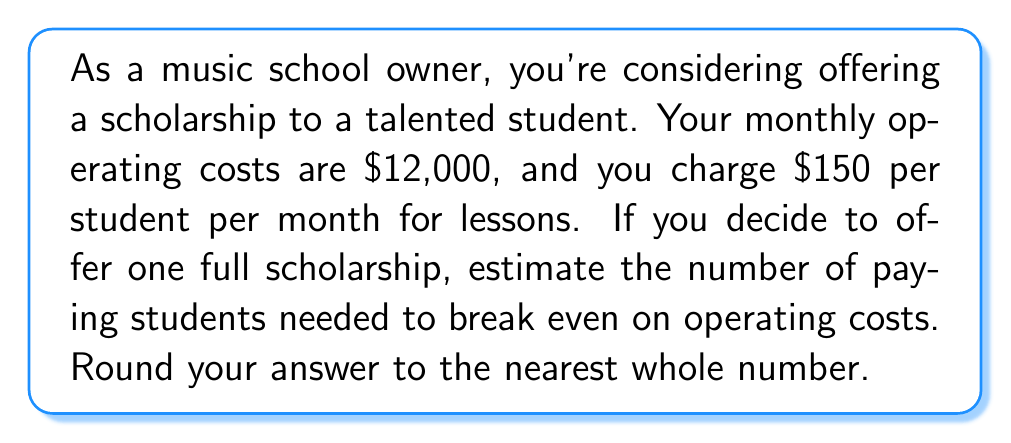What is the answer to this math problem? Let's approach this step-by-step:

1) First, we need to set up an equation to represent the break-even point:

   $$(Number of paying students) \times (Monthly fee) = Monthly operating costs + (Scholarship cost)$$

2) We know the following:
   - Monthly fee per student: $150
   - Monthly operating costs: $12,000
   - Scholarship cost: $150 (as it's one full scholarship)

3) Let's substitute these values into our equation, using $x$ to represent the number of paying students:

   $$150x = 12000 + 150$$

4) Simplify the right side of the equation:

   $$150x = 12150$$

5) Now, solve for $x$:

   $$x = \frac{12150}{150} = 81$$

6) Since we can't have a fractional number of students, and we're asked to round to the nearest whole number, our final answer is 81 students.

This means that with 81 paying students, the revenue will be:

$$81 \times $150 = $12,150$$

Which exactly covers the operating costs plus the scholarship.
Answer: 81 students 